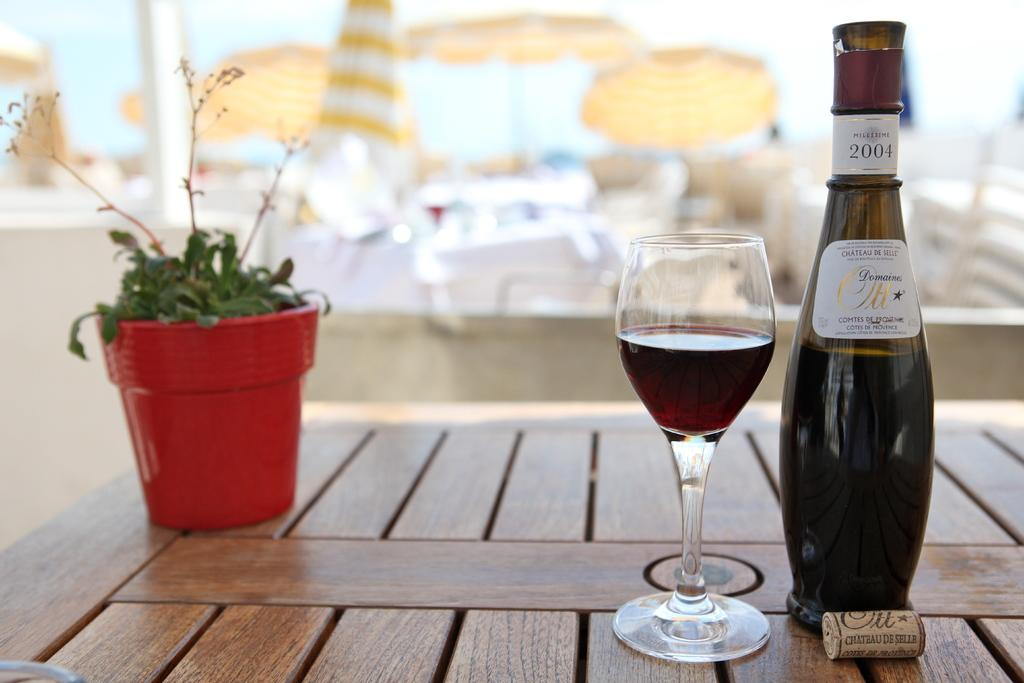What piece of furniture is present in the image? There is a table in the image. What type of object is on the table? There is a plant on the table. What else can be seen on the table? There is a bottle and a glass on the table. How many nuts are required to grip the plant in the image? There are no nuts present in the image, and the plant does not require any nuts to grip it. 